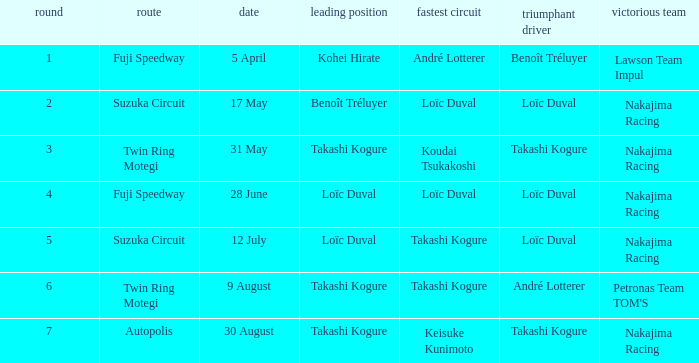What was the earlier round where Takashi Kogure got the fastest lap? 5.0. 